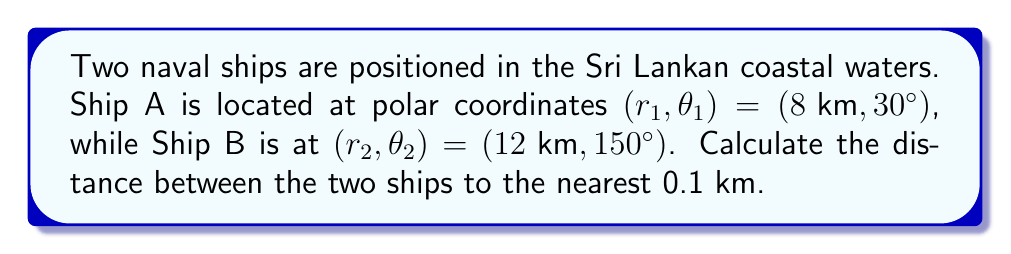Could you help me with this problem? To calculate the distance between two points in polar coordinates, we can use the polar form of the distance formula:

$$d = \sqrt{r_1^2 + r_2^2 - 2r_1r_2 \cos(\theta_2 - \theta_1)}$$

Let's substitute the given values:
$r_1 = 8 \text{ km}$
$r_2 = 12 \text{ km}$
$\theta_1 = 30°$
$\theta_2 = 150°$

First, calculate $\theta_2 - \theta_1$:
$$150° - 30° = 120°$$

Now, let's substitute all values into the formula:

$$\begin{align}
d &= \sqrt{8^2 + 12^2 - 2(8)(12) \cos(120°)} \\
&= \sqrt{64 + 144 - 192 \cos(120°)}
\end{align}$$

Recall that $\cos(120°) = -\frac{1}{2}$. Substituting this:

$$\begin{align}
d &= \sqrt{64 + 144 - 192 (-\frac{1}{2})} \\
&= \sqrt{64 + 144 + 96} \\
&= \sqrt{304} \\
&\approx 17.4356 \text{ km}
\end{align}$$

Rounding to the nearest 0.1 km, we get 17.4 km.

[asy]
import geometry;

size(200);
draw(circle((0,0),12), gray);
draw(circle((0,0),8), gray);
draw((0,0)--(12*cos(150*pi/180),12*sin(150*pi/180)), Arrow);
draw((0,0)--(8*cos(30*pi/180),8*sin(30*pi/180)), Arrow);
dot((12*cos(150*pi/180),12*sin(150*pi/180)));
dot((8*cos(30*pi/180),8*sin(30*pi/180)));
label("Ship B", (12*cos(150*pi/180),12*sin(150*pi/180)), NE);
label("Ship A", (8*cos(30*pi/180),8*sin(30*pi/180)), NE);
draw((12*cos(150*pi/180),12*sin(150*pi/180))--(8*cos(30*pi/180),8*sin(30*pi/180)), dashed);
[/asy]
Answer: The distance between the two ships is 17.4 km. 